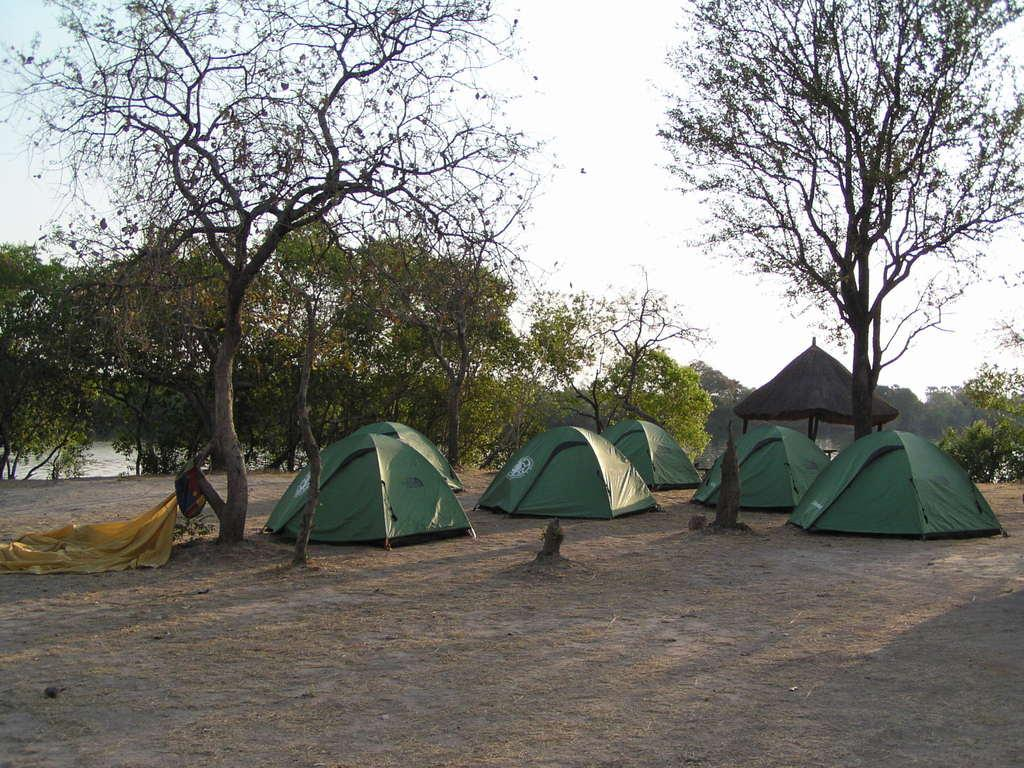What type of temporary shelters can be seen in the image? There are tents in the image. What natural elements are present in the image? There are trees and water visible in the image. What can be seen in the sky in the image? The sky is visible in the image. What type of structure is made of poles in the image? There is a pole hut in the image. How many rabbits can be seen in the image? There are no rabbits present in the image. What type of mine is visible in the image? There is no mine present in the image. 